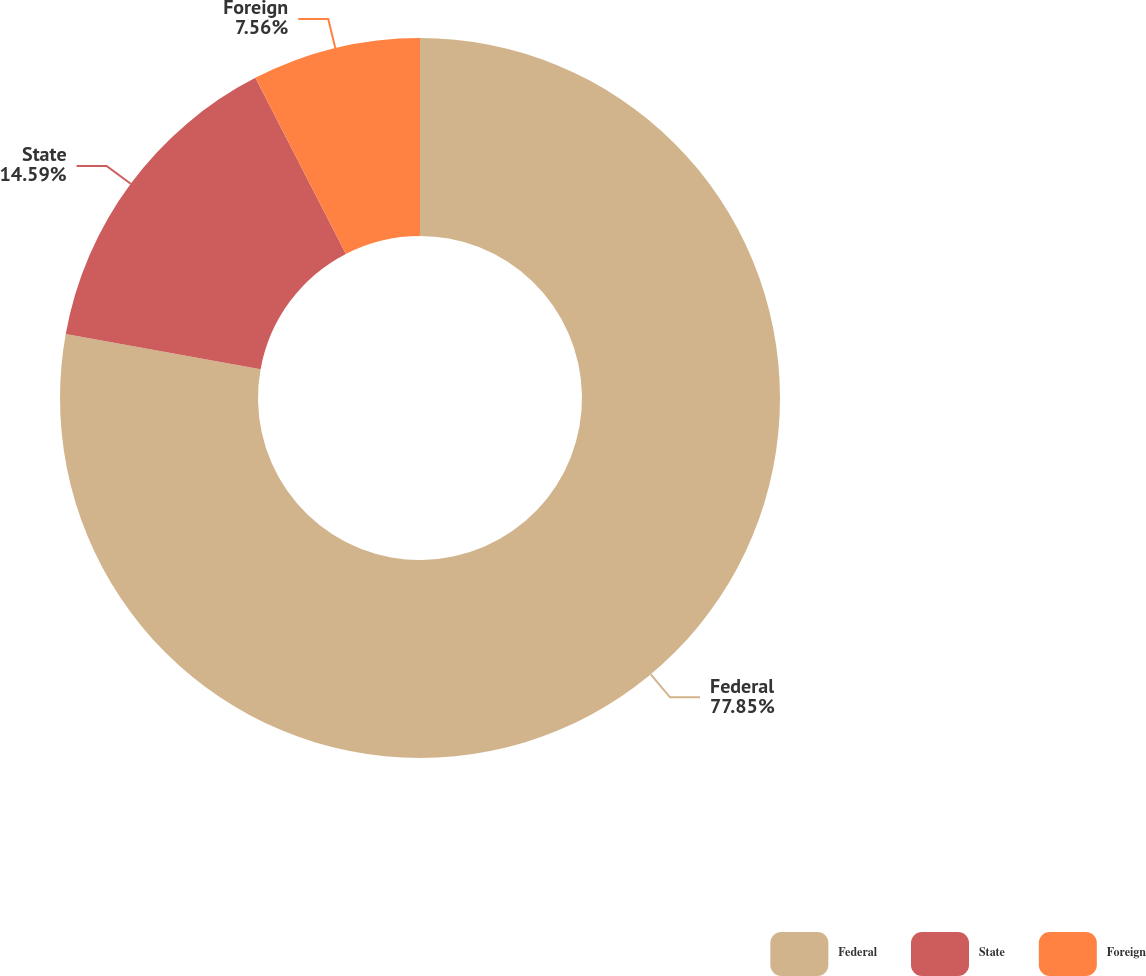Convert chart to OTSL. <chart><loc_0><loc_0><loc_500><loc_500><pie_chart><fcel>Federal<fcel>State<fcel>Foreign<nl><fcel>77.85%<fcel>14.59%<fcel>7.56%<nl></chart> 